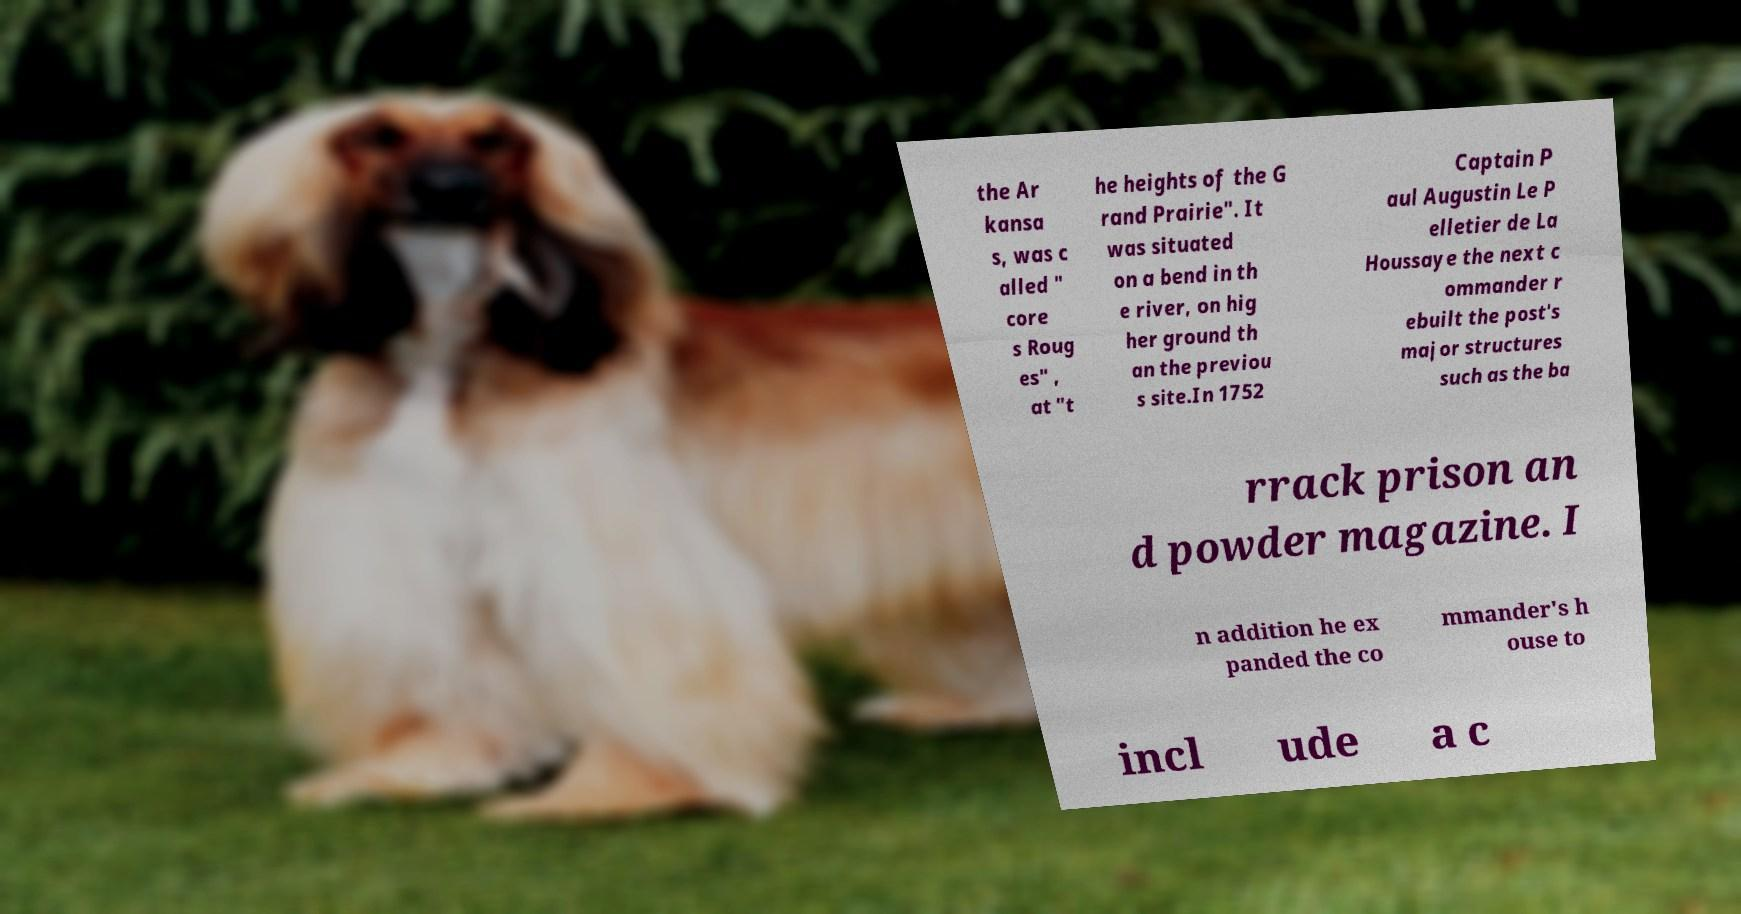Could you assist in decoding the text presented in this image and type it out clearly? the Ar kansa s, was c alled " core s Roug es" , at "t he heights of the G rand Prairie". It was situated on a bend in th e river, on hig her ground th an the previou s site.In 1752 Captain P aul Augustin Le P elletier de La Houssaye the next c ommander r ebuilt the post's major structures such as the ba rrack prison an d powder magazine. I n addition he ex panded the co mmander's h ouse to incl ude a c 